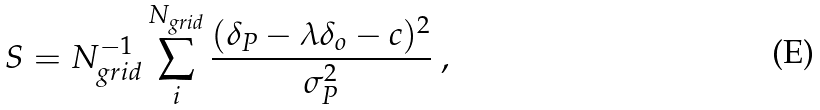Convert formula to latex. <formula><loc_0><loc_0><loc_500><loc_500>S = N _ { g r i d } ^ { - 1 } \sum _ { i } ^ { N _ { g r i d } } \frac { ( \delta _ { P } - \lambda \delta _ { o } - c ) ^ { 2 } } { \sigma _ { P } ^ { 2 } } \ ,</formula> 